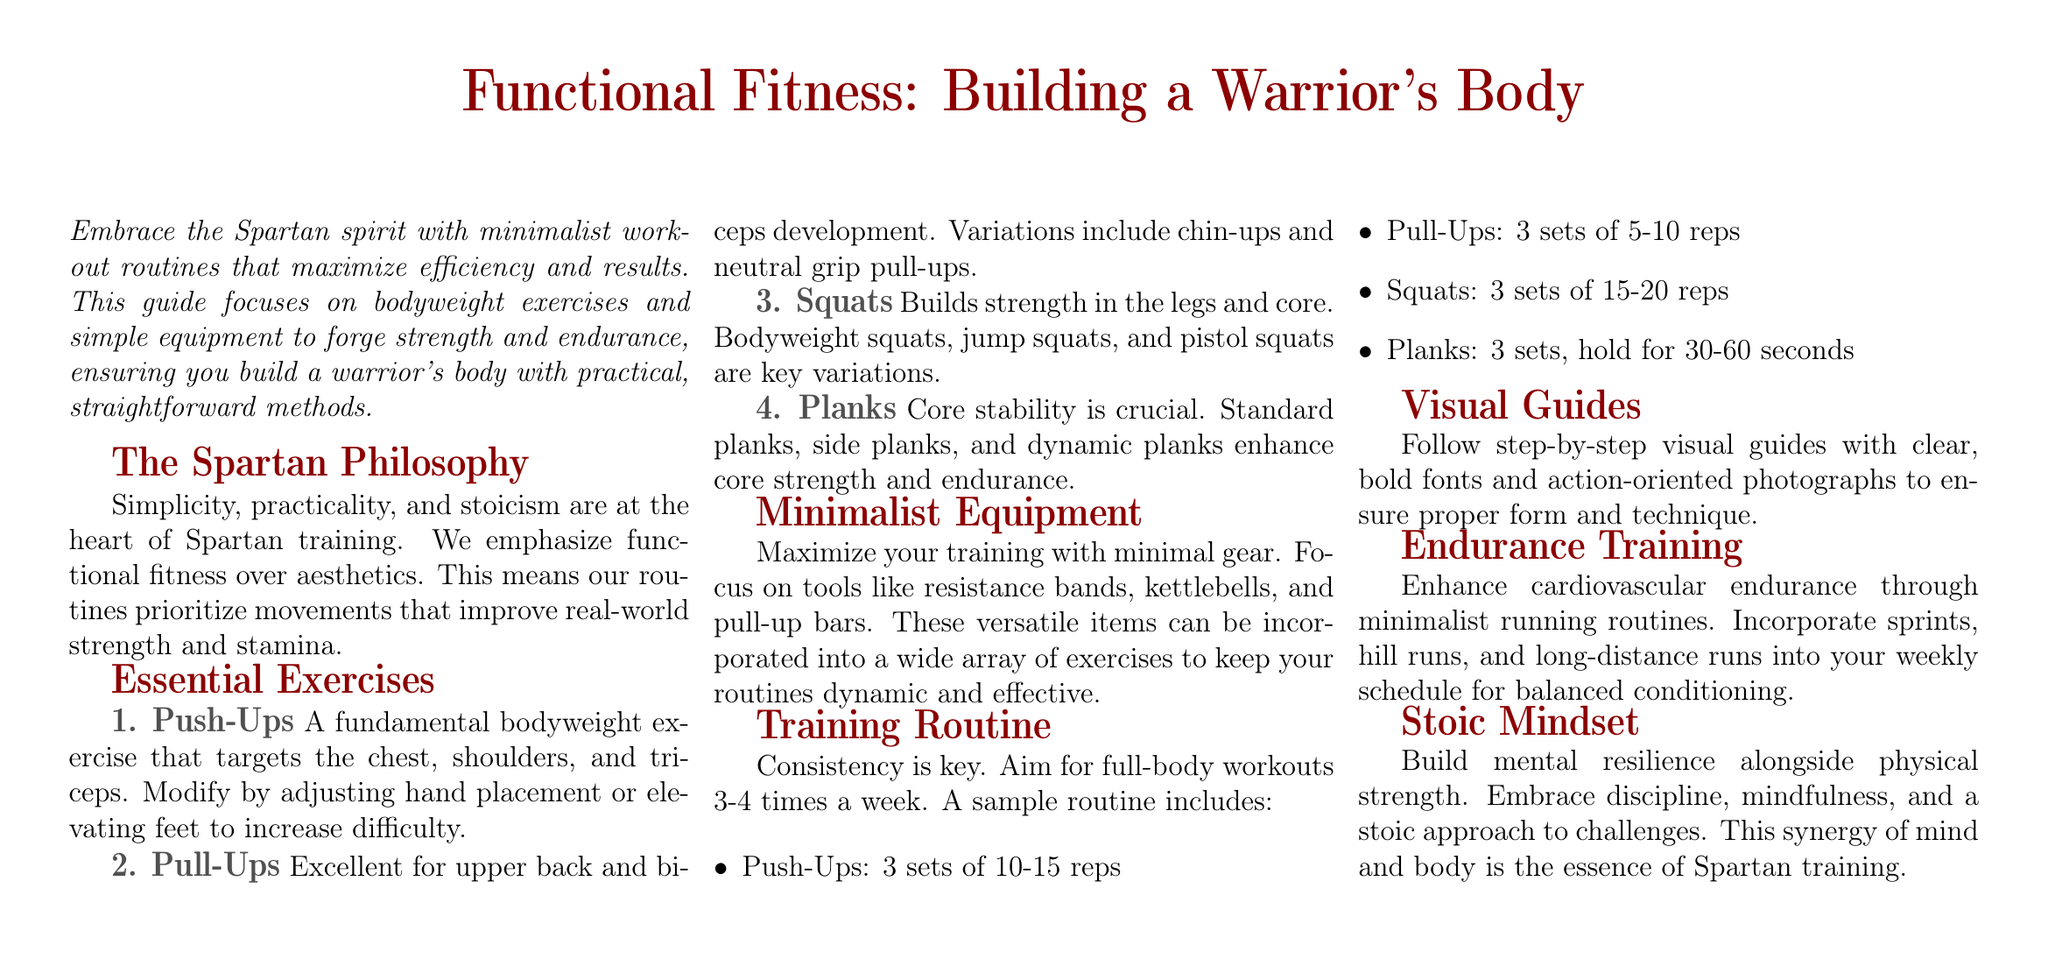What is the focus of the guide? The document emphasizes minimalist workout routines that maximize efficiency and results.
Answer: Minimalist workout routines What type of exercises are highlighted in the document? The exercises outlined are designed to build strength and endurance using bodyweight and minimal equipment.
Answer: Bodyweight exercises How many sets of push-ups are recommended? The document suggests performing 3 sets of push-ups to enhance strength.
Answer: 3 sets What is the primary goal of Spartan training? The document states that Spartan training prioritizes functional fitness over aesthetics, aiming to build real-world strength and stamina.
Answer: Functional fitness Which equipment is mentioned as essential for training? The document lists resistance bands, kettlebells, and pull-up bars as essential minimalist equipment.
Answer: Resistance bands, kettlebells, pull-up bars What aspect does the document emphasize alongside physical strength? The guide stresses the importance of developing a stoic mindset to build mental resilience.
Answer: Stoic mindset What is the recommended frequency of workouts per week? The document advises aiming for full-body workouts 3-4 times a week for optimal results.
Answer: 3-4 times a week What type of training enhances cardiovascular endurance? The document discusses incorporating minimalist running routines as a means to boost cardiovascular endurance.
Answer: Minimalist running routines What is the essence of Spartan training according to the document? The guide states that the combination of mental and physical strength embodies the essence of Spartan training.
Answer: Mind and body synergy 